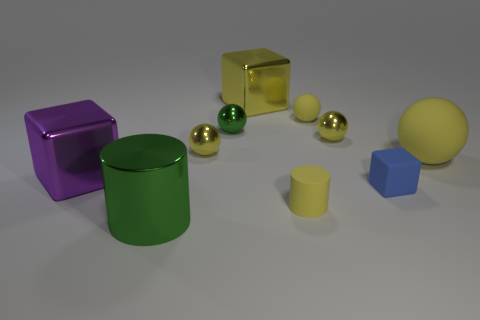Subtract all blue cubes. How many yellow balls are left? 4 Subtract all green metallic balls. How many balls are left? 4 Subtract all blue balls. Subtract all blue cylinders. How many balls are left? 5 Subtract all cubes. How many objects are left? 7 Subtract 0 red blocks. How many objects are left? 10 Subtract all small green spheres. Subtract all shiny cylinders. How many objects are left? 8 Add 1 yellow spheres. How many yellow spheres are left? 5 Add 5 tiny rubber blocks. How many tiny rubber blocks exist? 6 